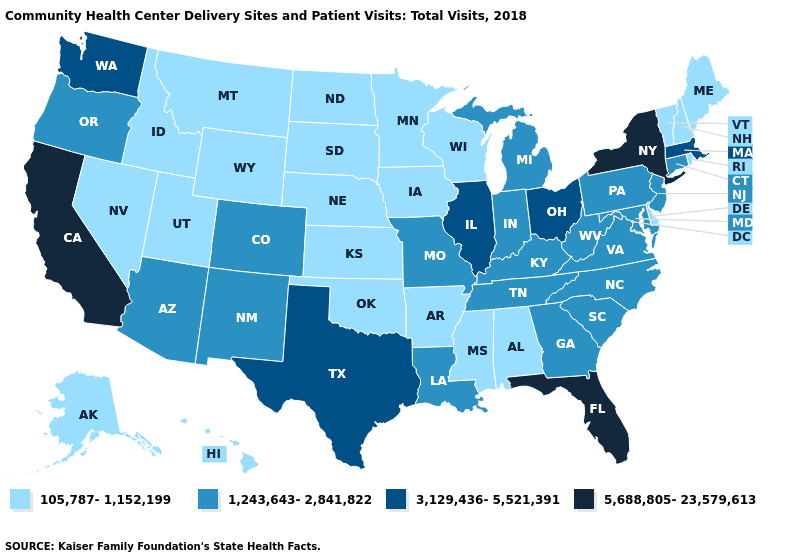Which states hav the highest value in the South?
Answer briefly. Florida. Which states hav the highest value in the West?
Quick response, please. California. Does Washington have the highest value in the USA?
Write a very short answer. No. What is the value of North Dakota?
Give a very brief answer. 105,787-1,152,199. Name the states that have a value in the range 5,688,805-23,579,613?
Quick response, please. California, Florida, New York. Name the states that have a value in the range 1,243,643-2,841,822?
Give a very brief answer. Arizona, Colorado, Connecticut, Georgia, Indiana, Kentucky, Louisiana, Maryland, Michigan, Missouri, New Jersey, New Mexico, North Carolina, Oregon, Pennsylvania, South Carolina, Tennessee, Virginia, West Virginia. What is the highest value in the USA?
Concise answer only. 5,688,805-23,579,613. Name the states that have a value in the range 5,688,805-23,579,613?
Quick response, please. California, Florida, New York. Does the first symbol in the legend represent the smallest category?
Concise answer only. Yes. What is the value of Maryland?
Give a very brief answer. 1,243,643-2,841,822. What is the lowest value in the USA?
Short answer required. 105,787-1,152,199. What is the value of Nebraska?
Quick response, please. 105,787-1,152,199. What is the value of Georgia?
Answer briefly. 1,243,643-2,841,822. Name the states that have a value in the range 3,129,436-5,521,391?
Give a very brief answer. Illinois, Massachusetts, Ohio, Texas, Washington. Does Georgia have the lowest value in the USA?
Concise answer only. No. 